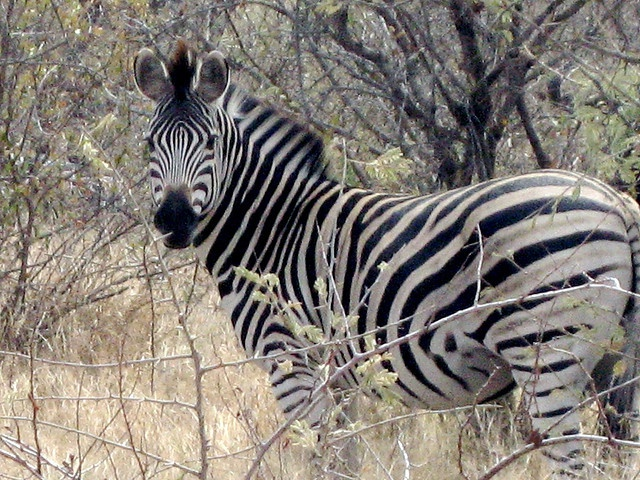Describe the objects in this image and their specific colors. I can see a zebra in gray, darkgray, black, and lightgray tones in this image. 